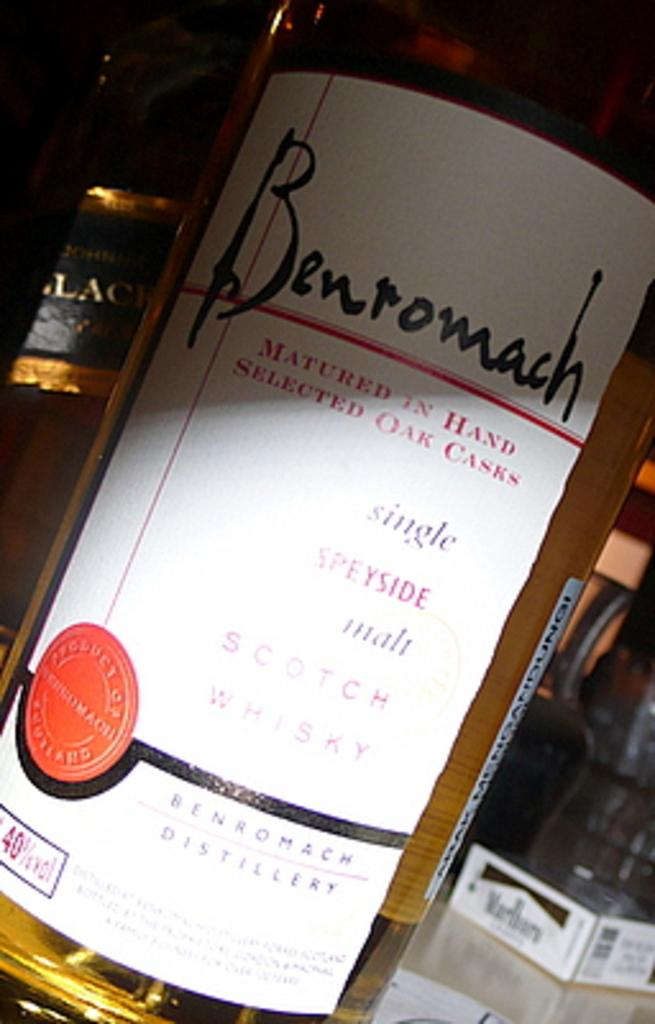Provide a one-sentence caption for the provided image. bottle of benromach wine matured in hand selected oak casks. 